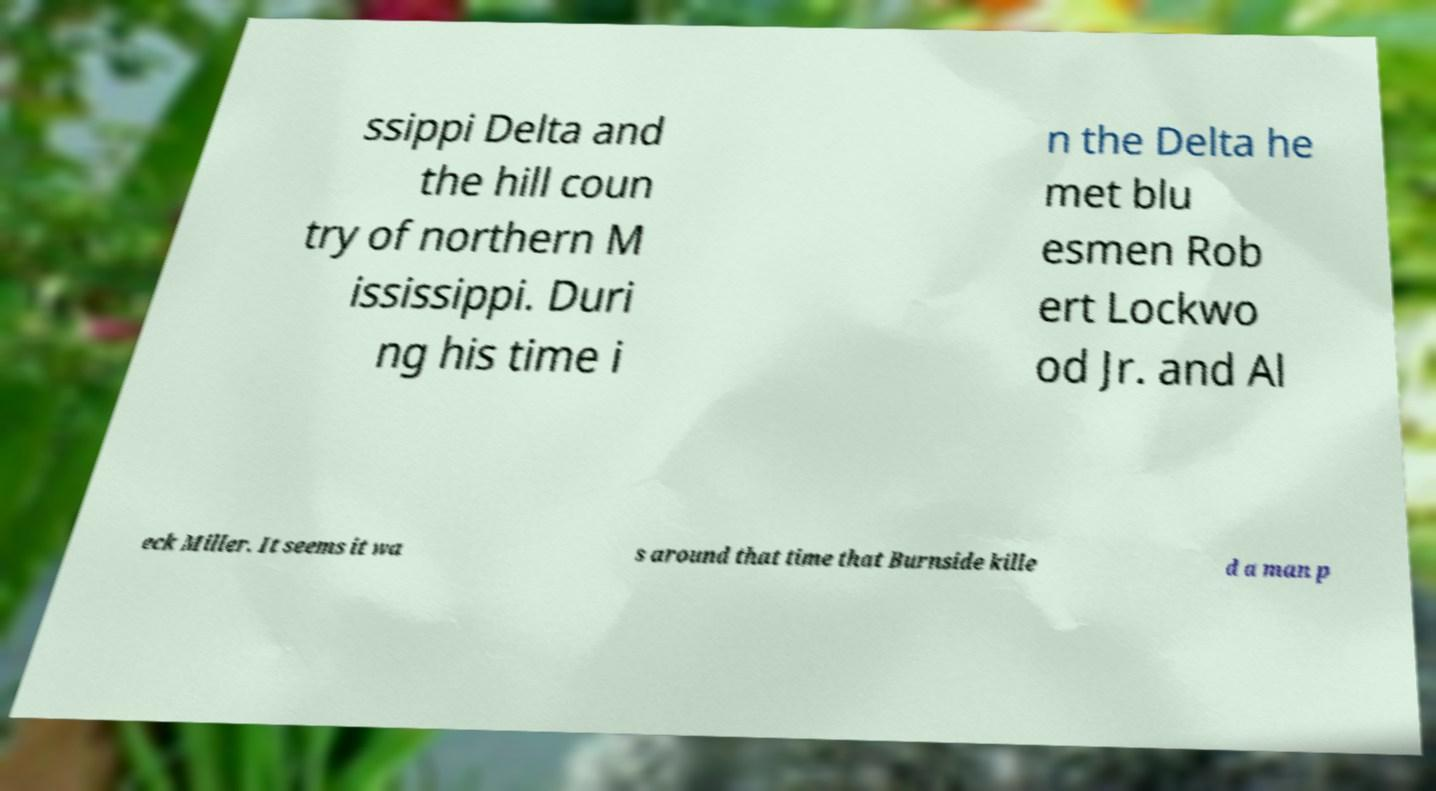Please identify and transcribe the text found in this image. ssippi Delta and the hill coun try of northern M ississippi. Duri ng his time i n the Delta he met blu esmen Rob ert Lockwo od Jr. and Al eck Miller. It seems it wa s around that time that Burnside kille d a man p 